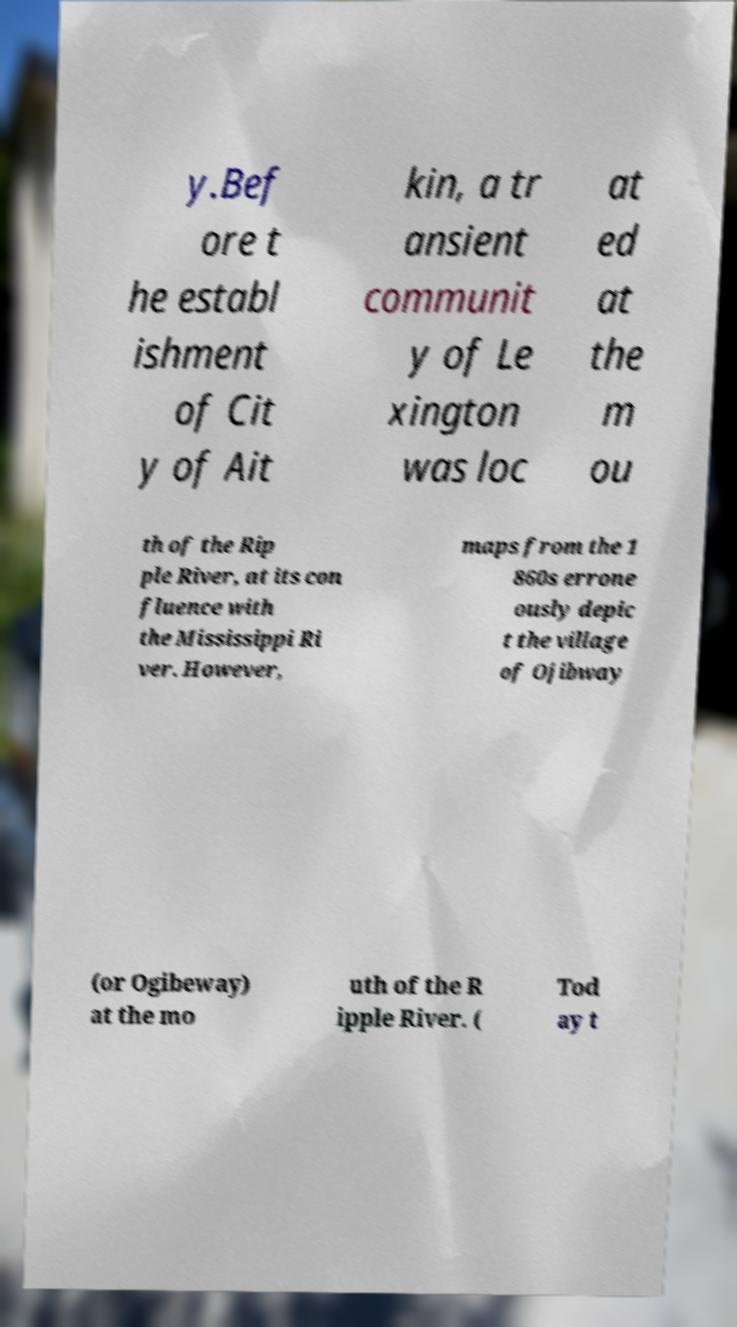There's text embedded in this image that I need extracted. Can you transcribe it verbatim? y.Bef ore t he establ ishment of Cit y of Ait kin, a tr ansient communit y of Le xington was loc at ed at the m ou th of the Rip ple River, at its con fluence with the Mississippi Ri ver. However, maps from the 1 860s errone ously depic t the village of Ojibway (or Ogibeway) at the mo uth of the R ipple River. ( Tod ay t 